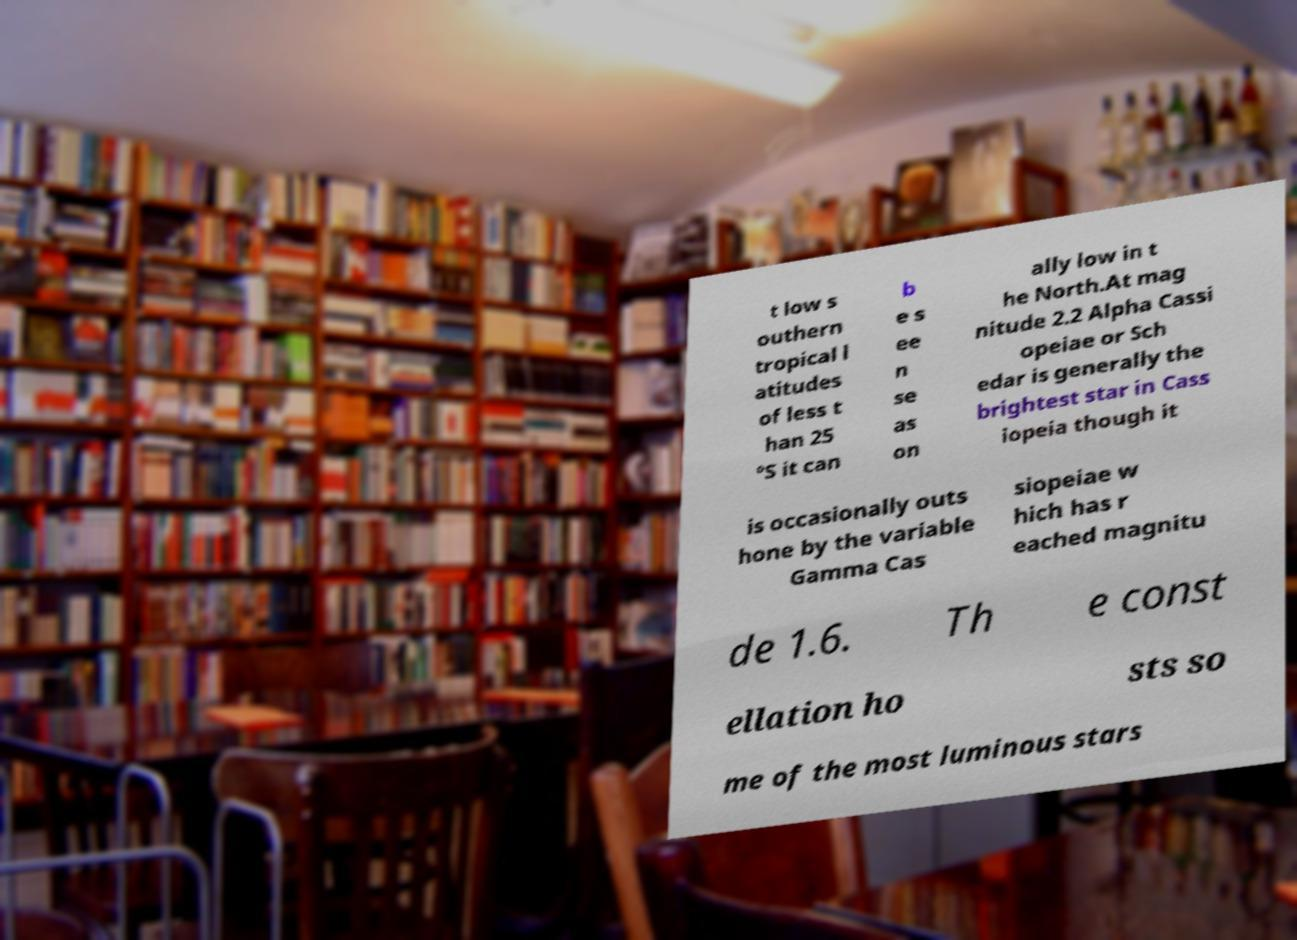Please read and relay the text visible in this image. What does it say? t low s outhern tropical l atitudes of less t han 25 °S it can b e s ee n se as on ally low in t he North.At mag nitude 2.2 Alpha Cassi opeiae or Sch edar is generally the brightest star in Cass iopeia though it is occasionally outs hone by the variable Gamma Cas siopeiae w hich has r eached magnitu de 1.6. Th e const ellation ho sts so me of the most luminous stars 